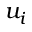Convert formula to latex. <formula><loc_0><loc_0><loc_500><loc_500>u _ { i }</formula> 